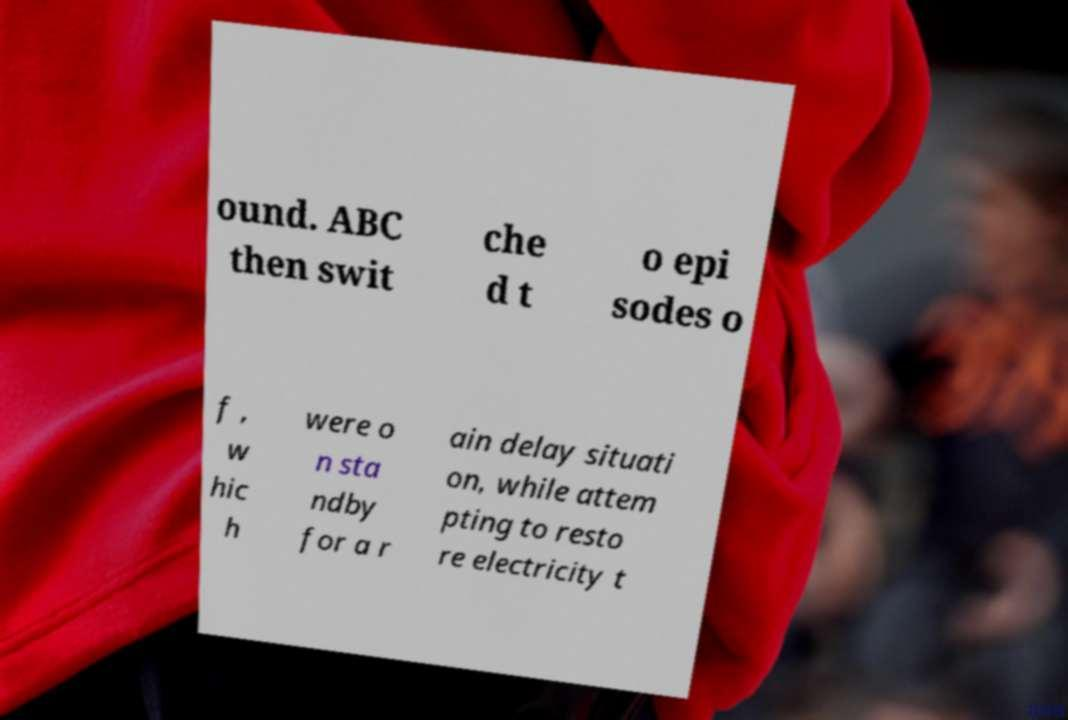Could you extract and type out the text from this image? ound. ABC then swit che d t o epi sodes o f , w hic h were o n sta ndby for a r ain delay situati on, while attem pting to resto re electricity t 